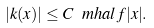Convert formula to latex. <formula><loc_0><loc_0><loc_500><loc_500>| k ( x ) | \leq C \ m h a l f { | x | } .</formula> 